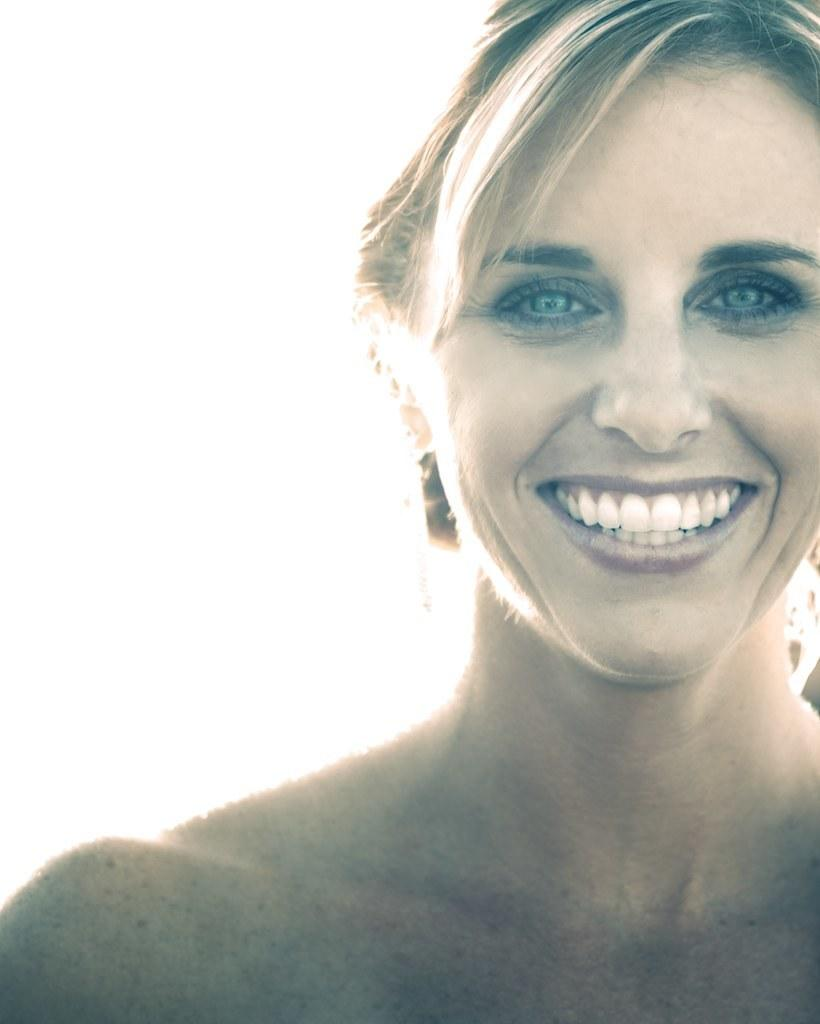Who is present in the image? There is a woman in the image. What expression does the woman have? The woman is smiling. What color is the background of the image? The background of the image is white. What type of fold can be seen in the woman's clothing in the image? There is no fold visible in the woman's clothing in the image. What emotion does the woman feel shame about in the image? There is no indication of shame or any other emotion besides happiness in the image, as the woman is smiling. 